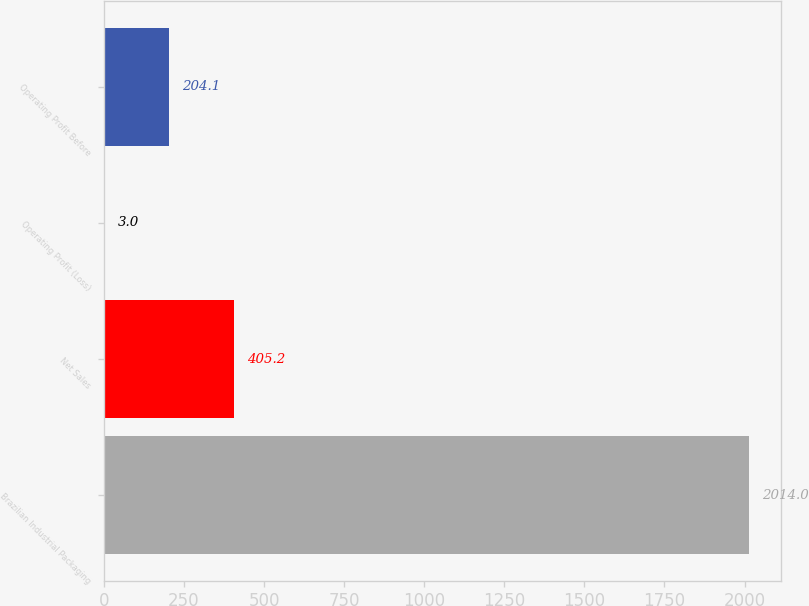<chart> <loc_0><loc_0><loc_500><loc_500><bar_chart><fcel>Brazilian Industrial Packaging<fcel>Net Sales<fcel>Operating Profit (Loss)<fcel>Operating Profit Before<nl><fcel>2014<fcel>405.2<fcel>3<fcel>204.1<nl></chart> 